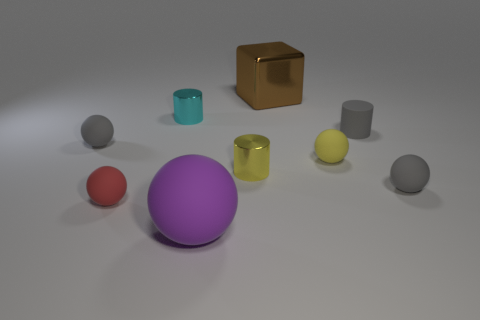How many other things are the same size as the yellow matte thing?
Offer a terse response. 6. Do the large metal object and the red matte object have the same shape?
Offer a very short reply. No. There is a yellow object that is the same shape as the tiny cyan object; what material is it?
Provide a short and direct response. Metal. What number of tiny cylinders are the same color as the large metallic block?
Give a very brief answer. 0. What size is the gray cylinder that is the same material as the red ball?
Give a very brief answer. Small. How many yellow objects are metal cylinders or tiny rubber spheres?
Make the answer very short. 2. How many small cyan objects are behind the cylinder to the left of the big purple rubber ball?
Your answer should be very brief. 0. Are there more purple rubber balls that are right of the large matte sphere than cyan metal cylinders that are right of the brown metal block?
Offer a terse response. No. What material is the cube?
Your answer should be compact. Metal. Is there a sphere of the same size as the cyan object?
Make the answer very short. Yes. 